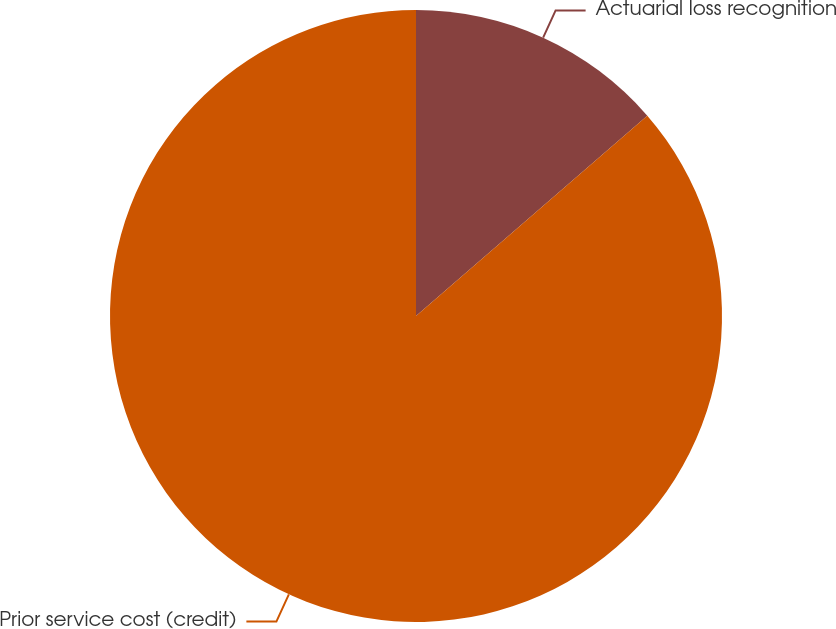Convert chart to OTSL. <chart><loc_0><loc_0><loc_500><loc_500><pie_chart><fcel>Actuarial loss recognition<fcel>Prior service cost (credit)<nl><fcel>13.64%<fcel>86.36%<nl></chart> 